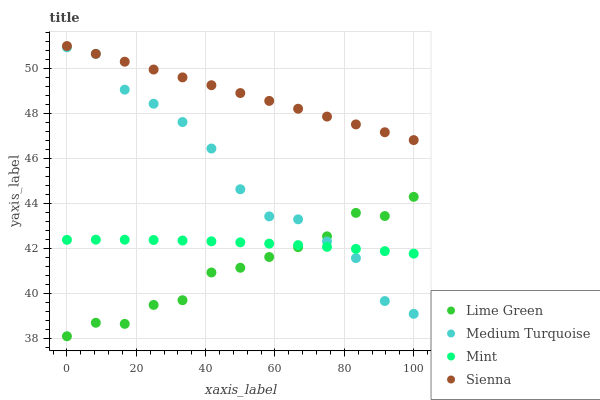Does Lime Green have the minimum area under the curve?
Answer yes or no. Yes. Does Sienna have the maximum area under the curve?
Answer yes or no. Yes. Does Mint have the minimum area under the curve?
Answer yes or no. No. Does Mint have the maximum area under the curve?
Answer yes or no. No. Is Sienna the smoothest?
Answer yes or no. Yes. Is Medium Turquoise the roughest?
Answer yes or no. Yes. Is Mint the smoothest?
Answer yes or no. No. Is Mint the roughest?
Answer yes or no. No. Does Lime Green have the lowest value?
Answer yes or no. Yes. Does Mint have the lowest value?
Answer yes or no. No. Does Sienna have the highest value?
Answer yes or no. Yes. Does Lime Green have the highest value?
Answer yes or no. No. Is Mint less than Sienna?
Answer yes or no. Yes. Is Sienna greater than Medium Turquoise?
Answer yes or no. Yes. Does Medium Turquoise intersect Mint?
Answer yes or no. Yes. Is Medium Turquoise less than Mint?
Answer yes or no. No. Is Medium Turquoise greater than Mint?
Answer yes or no. No. Does Mint intersect Sienna?
Answer yes or no. No. 